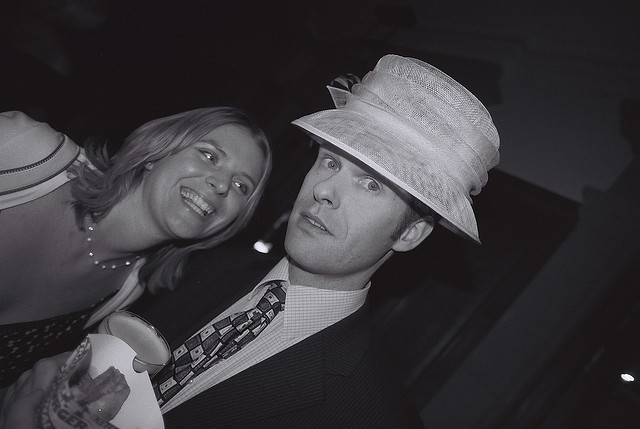How many hats? There is one hat visible in the image, worn by the gentleman dressed in a suit. 